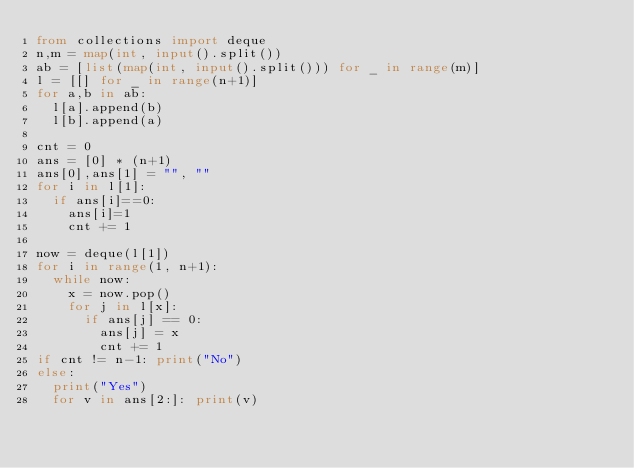<code> <loc_0><loc_0><loc_500><loc_500><_Python_>from collections import deque
n,m = map(int, input().split())
ab = [list(map(int, input().split())) for _ in range(m)]
l = [[] for _ in range(n+1)]
for a,b in ab:
  l[a].append(b)
  l[b].append(a)

cnt = 0
ans = [0] * (n+1)
ans[0],ans[1] = "", ""
for i in l[1]:
  if ans[i]==0: 
    ans[i]=1
    cnt += 1

now = deque(l[1])
for i in range(1, n+1):
  while now:
    x = now.pop()
    for j in l[x]:
      if ans[j] == 0: 
        ans[j] = x
        cnt += 1
if cnt != n-1: print("No")
else:
  print("Yes")
  for v in ans[2:]: print(v)</code> 